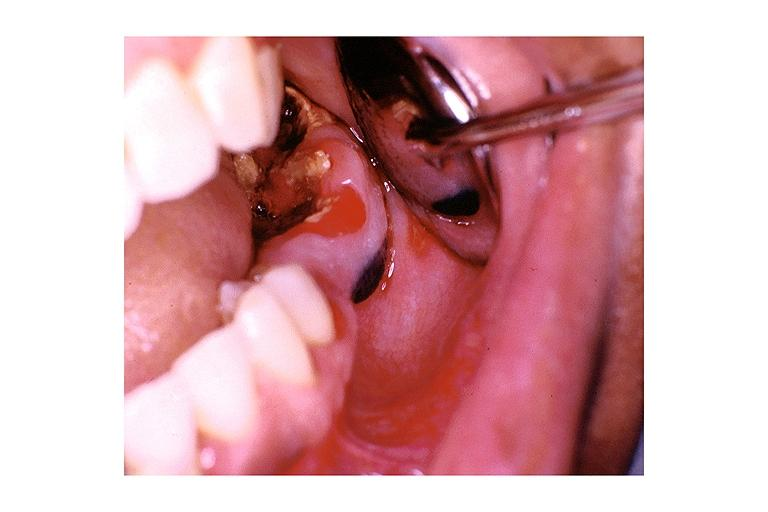what does this image show?
Answer the question using a single word or phrase. Nevus 